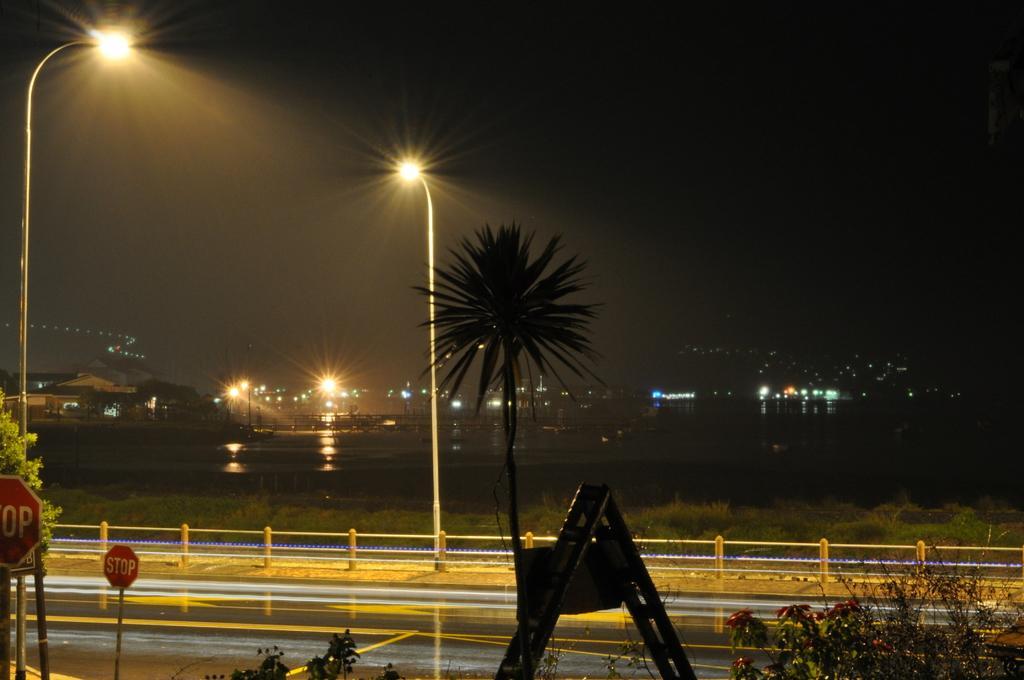How would you summarize this image in a sentence or two? In the image we can see there are plants and trees. There are sign boards on which its written ¨Stop¨ and there is a ladder kept on the ground. There are iron poles fencing and there are street light poles. Behind the background is dark and the sky is dark. 